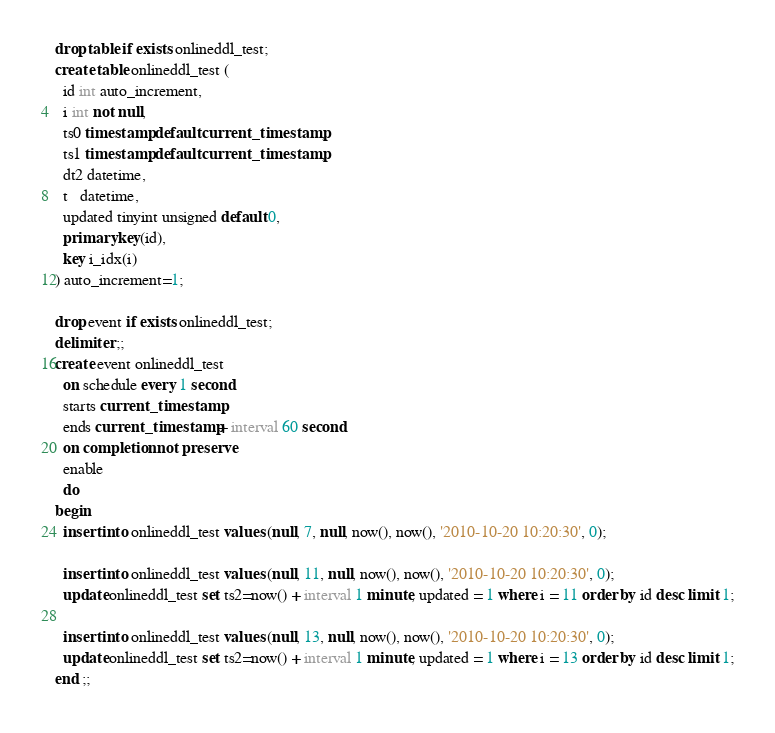Convert code to text. <code><loc_0><loc_0><loc_500><loc_500><_SQL_>drop table if exists onlineddl_test;
create table onlineddl_test (
  id int auto_increment,
  i int not null,
  ts0 timestamp default current_timestamp,
  ts1 timestamp default current_timestamp,
  dt2 datetime,
  t   datetime,
  updated tinyint unsigned default 0,
  primary key(id),
  key i_idx(i)
) auto_increment=1;

drop event if exists onlineddl_test;
delimiter ;;
create event onlineddl_test
  on schedule every 1 second
  starts current_timestamp
  ends current_timestamp + interval 60 second
  on completion not preserve
  enable
  do
begin
  insert into onlineddl_test values (null, 7, null, now(), now(), '2010-10-20 10:20:30', 0);

  insert into onlineddl_test values (null, 11, null, now(), now(), '2010-10-20 10:20:30', 0);
  update onlineddl_test set ts2=now() + interval 1 minute, updated = 1 where i = 11 order by id desc limit 1;

  insert into onlineddl_test values (null, 13, null, now(), now(), '2010-10-20 10:20:30', 0);
  update onlineddl_test set ts2=now() + interval 1 minute, updated = 1 where i = 13 order by id desc limit 1;
end ;;
</code> 